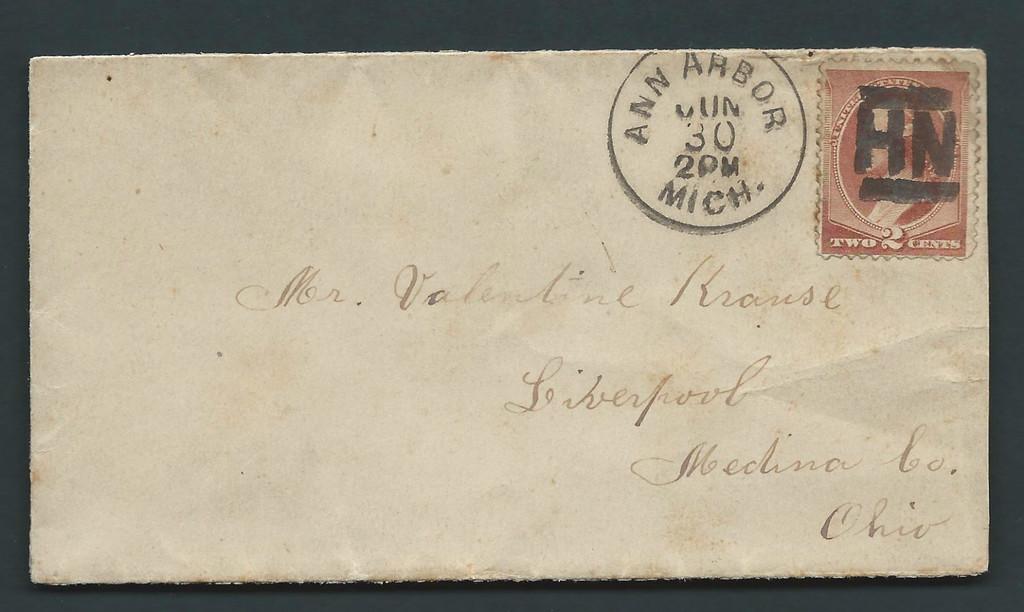How many cents did the stamp cost?
Your response must be concise. 2. Which michigan city was the letter postmarked in?
Your response must be concise. Ann arbor. 